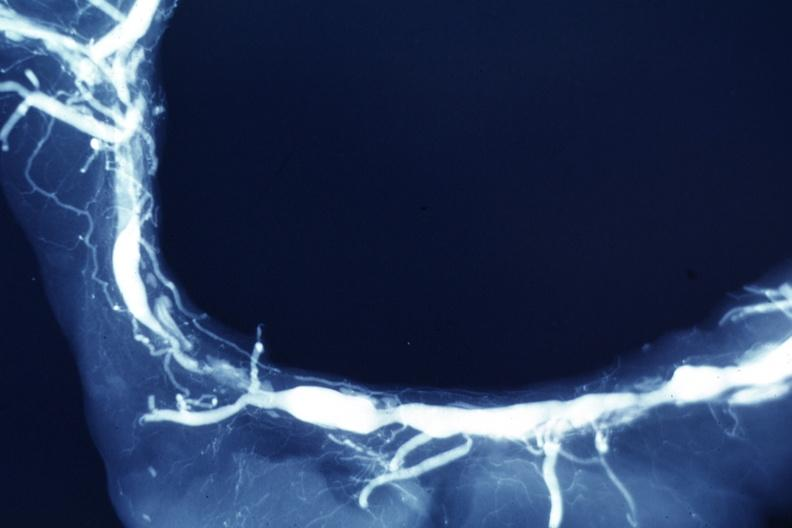s retroperitoneal liposarcoma present?
Answer the question using a single word or phrase. No 